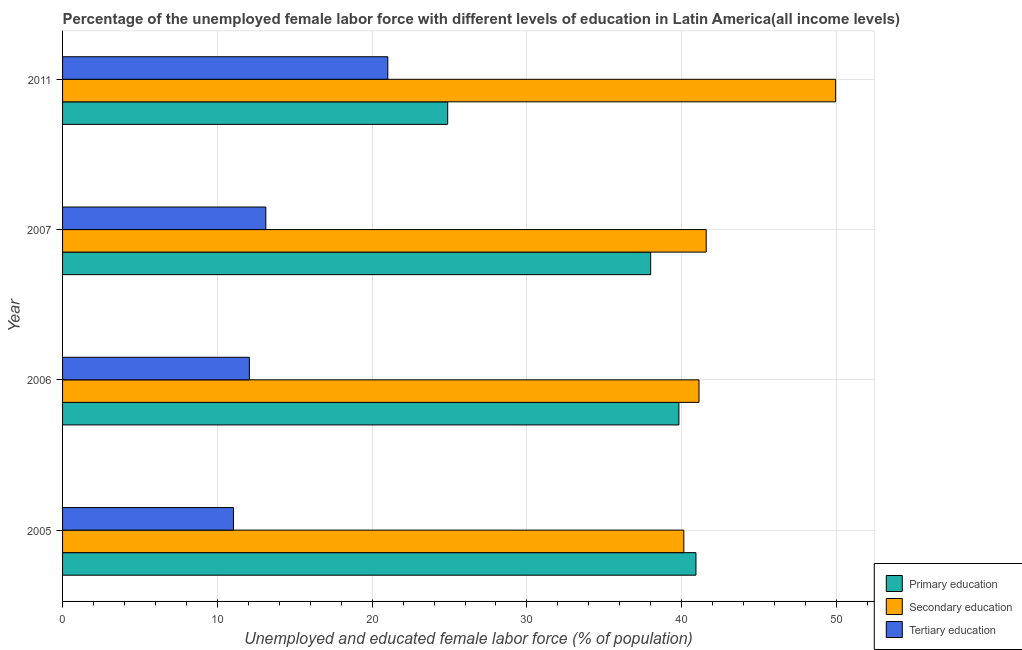How many different coloured bars are there?
Keep it short and to the point. 3. How many groups of bars are there?
Make the answer very short. 4. How many bars are there on the 2nd tick from the bottom?
Provide a short and direct response. 3. What is the label of the 2nd group of bars from the top?
Offer a terse response. 2007. In how many cases, is the number of bars for a given year not equal to the number of legend labels?
Offer a very short reply. 0. What is the percentage of female labor force who received secondary education in 2007?
Keep it short and to the point. 41.58. Across all years, what is the maximum percentage of female labor force who received tertiary education?
Give a very brief answer. 21.01. Across all years, what is the minimum percentage of female labor force who received primary education?
Your answer should be compact. 24.88. In which year was the percentage of female labor force who received tertiary education maximum?
Ensure brevity in your answer.  2011. In which year was the percentage of female labor force who received primary education minimum?
Keep it short and to the point. 2011. What is the total percentage of female labor force who received tertiary education in the graph?
Offer a terse response. 57.26. What is the difference between the percentage of female labor force who received tertiary education in 2005 and that in 2007?
Provide a succinct answer. -2.09. What is the difference between the percentage of female labor force who received tertiary education in 2007 and the percentage of female labor force who received secondary education in 2005?
Make the answer very short. -27. What is the average percentage of female labor force who received primary education per year?
Ensure brevity in your answer.  35.9. In the year 2006, what is the difference between the percentage of female labor force who received secondary education and percentage of female labor force who received tertiary education?
Keep it short and to the point. 29.05. In how many years, is the percentage of female labor force who received tertiary education greater than 46 %?
Offer a terse response. 0. What is the ratio of the percentage of female labor force who received primary education in 2007 to that in 2011?
Keep it short and to the point. 1.53. Is the percentage of female labor force who received secondary education in 2006 less than that in 2011?
Provide a short and direct response. Yes. Is the difference between the percentage of female labor force who received primary education in 2005 and 2007 greater than the difference between the percentage of female labor force who received tertiary education in 2005 and 2007?
Ensure brevity in your answer.  Yes. What is the difference between the highest and the second highest percentage of female labor force who received secondary education?
Make the answer very short. 8.36. What is the difference between the highest and the lowest percentage of female labor force who received primary education?
Ensure brevity in your answer.  16.04. What does the 3rd bar from the top in 2006 represents?
Your answer should be very brief. Primary education. What does the 1st bar from the bottom in 2005 represents?
Keep it short and to the point. Primary education. Is it the case that in every year, the sum of the percentage of female labor force who received primary education and percentage of female labor force who received secondary education is greater than the percentage of female labor force who received tertiary education?
Your answer should be very brief. Yes. How many bars are there?
Your response must be concise. 12. Are all the bars in the graph horizontal?
Make the answer very short. Yes. How many years are there in the graph?
Provide a succinct answer. 4. What is the difference between two consecutive major ticks on the X-axis?
Provide a succinct answer. 10. Are the values on the major ticks of X-axis written in scientific E-notation?
Your answer should be compact. No. Does the graph contain any zero values?
Provide a short and direct response. No. Where does the legend appear in the graph?
Offer a very short reply. Bottom right. What is the title of the graph?
Provide a succinct answer. Percentage of the unemployed female labor force with different levels of education in Latin America(all income levels). What is the label or title of the X-axis?
Give a very brief answer. Unemployed and educated female labor force (% of population). What is the Unemployed and educated female labor force (% of population) of Primary education in 2005?
Your answer should be compact. 40.92. What is the Unemployed and educated female labor force (% of population) of Secondary education in 2005?
Your response must be concise. 40.14. What is the Unemployed and educated female labor force (% of population) in Tertiary education in 2005?
Offer a terse response. 11.04. What is the Unemployed and educated female labor force (% of population) of Primary education in 2006?
Make the answer very short. 39.82. What is the Unemployed and educated female labor force (% of population) in Secondary education in 2006?
Ensure brevity in your answer.  41.12. What is the Unemployed and educated female labor force (% of population) in Tertiary education in 2006?
Provide a succinct answer. 12.07. What is the Unemployed and educated female labor force (% of population) in Primary education in 2007?
Your answer should be very brief. 38. What is the Unemployed and educated female labor force (% of population) in Secondary education in 2007?
Offer a terse response. 41.58. What is the Unemployed and educated female labor force (% of population) in Tertiary education in 2007?
Provide a short and direct response. 13.13. What is the Unemployed and educated female labor force (% of population) of Primary education in 2011?
Make the answer very short. 24.88. What is the Unemployed and educated female labor force (% of population) of Secondary education in 2011?
Your answer should be compact. 49.94. What is the Unemployed and educated female labor force (% of population) in Tertiary education in 2011?
Offer a very short reply. 21.01. Across all years, what is the maximum Unemployed and educated female labor force (% of population) of Primary education?
Your answer should be compact. 40.92. Across all years, what is the maximum Unemployed and educated female labor force (% of population) in Secondary education?
Keep it short and to the point. 49.94. Across all years, what is the maximum Unemployed and educated female labor force (% of population) in Tertiary education?
Offer a terse response. 21.01. Across all years, what is the minimum Unemployed and educated female labor force (% of population) in Primary education?
Make the answer very short. 24.88. Across all years, what is the minimum Unemployed and educated female labor force (% of population) in Secondary education?
Your response must be concise. 40.14. Across all years, what is the minimum Unemployed and educated female labor force (% of population) of Tertiary education?
Your answer should be compact. 11.04. What is the total Unemployed and educated female labor force (% of population) in Primary education in the graph?
Ensure brevity in your answer.  143.62. What is the total Unemployed and educated female labor force (% of population) in Secondary education in the graph?
Your answer should be compact. 172.78. What is the total Unemployed and educated female labor force (% of population) of Tertiary education in the graph?
Give a very brief answer. 57.26. What is the difference between the Unemployed and educated female labor force (% of population) in Primary education in 2005 and that in 2006?
Your response must be concise. 1.1. What is the difference between the Unemployed and educated female labor force (% of population) of Secondary education in 2005 and that in 2006?
Your answer should be very brief. -0.98. What is the difference between the Unemployed and educated female labor force (% of population) of Tertiary education in 2005 and that in 2006?
Provide a short and direct response. -1.03. What is the difference between the Unemployed and educated female labor force (% of population) of Primary education in 2005 and that in 2007?
Your response must be concise. 2.92. What is the difference between the Unemployed and educated female labor force (% of population) in Secondary education in 2005 and that in 2007?
Keep it short and to the point. -1.45. What is the difference between the Unemployed and educated female labor force (% of population) in Tertiary education in 2005 and that in 2007?
Keep it short and to the point. -2.09. What is the difference between the Unemployed and educated female labor force (% of population) in Primary education in 2005 and that in 2011?
Provide a short and direct response. 16.04. What is the difference between the Unemployed and educated female labor force (% of population) in Secondary education in 2005 and that in 2011?
Your response must be concise. -9.81. What is the difference between the Unemployed and educated female labor force (% of population) in Tertiary education in 2005 and that in 2011?
Provide a short and direct response. -9.97. What is the difference between the Unemployed and educated female labor force (% of population) of Primary education in 2006 and that in 2007?
Offer a very short reply. 1.82. What is the difference between the Unemployed and educated female labor force (% of population) in Secondary education in 2006 and that in 2007?
Make the answer very short. -0.47. What is the difference between the Unemployed and educated female labor force (% of population) in Tertiary education in 2006 and that in 2007?
Your answer should be compact. -1.06. What is the difference between the Unemployed and educated female labor force (% of population) of Primary education in 2006 and that in 2011?
Offer a very short reply. 14.94. What is the difference between the Unemployed and educated female labor force (% of population) of Secondary education in 2006 and that in 2011?
Your answer should be compact. -8.83. What is the difference between the Unemployed and educated female labor force (% of population) in Tertiary education in 2006 and that in 2011?
Offer a terse response. -8.94. What is the difference between the Unemployed and educated female labor force (% of population) of Primary education in 2007 and that in 2011?
Your response must be concise. 13.12. What is the difference between the Unemployed and educated female labor force (% of population) of Secondary education in 2007 and that in 2011?
Keep it short and to the point. -8.36. What is the difference between the Unemployed and educated female labor force (% of population) in Tertiary education in 2007 and that in 2011?
Your answer should be very brief. -7.88. What is the difference between the Unemployed and educated female labor force (% of population) in Primary education in 2005 and the Unemployed and educated female labor force (% of population) in Secondary education in 2006?
Provide a short and direct response. -0.2. What is the difference between the Unemployed and educated female labor force (% of population) in Primary education in 2005 and the Unemployed and educated female labor force (% of population) in Tertiary education in 2006?
Make the answer very short. 28.85. What is the difference between the Unemployed and educated female labor force (% of population) of Secondary education in 2005 and the Unemployed and educated female labor force (% of population) of Tertiary education in 2006?
Ensure brevity in your answer.  28.07. What is the difference between the Unemployed and educated female labor force (% of population) of Primary education in 2005 and the Unemployed and educated female labor force (% of population) of Secondary education in 2007?
Your response must be concise. -0.66. What is the difference between the Unemployed and educated female labor force (% of population) of Primary education in 2005 and the Unemployed and educated female labor force (% of population) of Tertiary education in 2007?
Keep it short and to the point. 27.79. What is the difference between the Unemployed and educated female labor force (% of population) of Secondary education in 2005 and the Unemployed and educated female labor force (% of population) of Tertiary education in 2007?
Your answer should be very brief. 27. What is the difference between the Unemployed and educated female labor force (% of population) of Primary education in 2005 and the Unemployed and educated female labor force (% of population) of Secondary education in 2011?
Provide a succinct answer. -9.02. What is the difference between the Unemployed and educated female labor force (% of population) in Primary education in 2005 and the Unemployed and educated female labor force (% of population) in Tertiary education in 2011?
Your response must be concise. 19.91. What is the difference between the Unemployed and educated female labor force (% of population) of Secondary education in 2005 and the Unemployed and educated female labor force (% of population) of Tertiary education in 2011?
Provide a succinct answer. 19.12. What is the difference between the Unemployed and educated female labor force (% of population) in Primary education in 2006 and the Unemployed and educated female labor force (% of population) in Secondary education in 2007?
Offer a terse response. -1.76. What is the difference between the Unemployed and educated female labor force (% of population) in Primary education in 2006 and the Unemployed and educated female labor force (% of population) in Tertiary education in 2007?
Ensure brevity in your answer.  26.69. What is the difference between the Unemployed and educated female labor force (% of population) in Secondary education in 2006 and the Unemployed and educated female labor force (% of population) in Tertiary education in 2007?
Offer a very short reply. 27.99. What is the difference between the Unemployed and educated female labor force (% of population) in Primary education in 2006 and the Unemployed and educated female labor force (% of population) in Secondary education in 2011?
Provide a succinct answer. -10.13. What is the difference between the Unemployed and educated female labor force (% of population) in Primary education in 2006 and the Unemployed and educated female labor force (% of population) in Tertiary education in 2011?
Offer a terse response. 18.81. What is the difference between the Unemployed and educated female labor force (% of population) of Secondary education in 2006 and the Unemployed and educated female labor force (% of population) of Tertiary education in 2011?
Your answer should be compact. 20.1. What is the difference between the Unemployed and educated female labor force (% of population) in Primary education in 2007 and the Unemployed and educated female labor force (% of population) in Secondary education in 2011?
Ensure brevity in your answer.  -11.95. What is the difference between the Unemployed and educated female labor force (% of population) of Primary education in 2007 and the Unemployed and educated female labor force (% of population) of Tertiary education in 2011?
Your response must be concise. 16.98. What is the difference between the Unemployed and educated female labor force (% of population) of Secondary education in 2007 and the Unemployed and educated female labor force (% of population) of Tertiary education in 2011?
Your response must be concise. 20.57. What is the average Unemployed and educated female labor force (% of population) in Primary education per year?
Your answer should be compact. 35.9. What is the average Unemployed and educated female labor force (% of population) in Secondary education per year?
Keep it short and to the point. 43.19. What is the average Unemployed and educated female labor force (% of population) in Tertiary education per year?
Offer a terse response. 14.31. In the year 2005, what is the difference between the Unemployed and educated female labor force (% of population) of Primary education and Unemployed and educated female labor force (% of population) of Secondary education?
Your response must be concise. 0.78. In the year 2005, what is the difference between the Unemployed and educated female labor force (% of population) in Primary education and Unemployed and educated female labor force (% of population) in Tertiary education?
Your response must be concise. 29.88. In the year 2005, what is the difference between the Unemployed and educated female labor force (% of population) of Secondary education and Unemployed and educated female labor force (% of population) of Tertiary education?
Offer a terse response. 29.1. In the year 2006, what is the difference between the Unemployed and educated female labor force (% of population) of Primary education and Unemployed and educated female labor force (% of population) of Secondary education?
Provide a succinct answer. -1.3. In the year 2006, what is the difference between the Unemployed and educated female labor force (% of population) of Primary education and Unemployed and educated female labor force (% of population) of Tertiary education?
Offer a very short reply. 27.75. In the year 2006, what is the difference between the Unemployed and educated female labor force (% of population) in Secondary education and Unemployed and educated female labor force (% of population) in Tertiary education?
Your answer should be very brief. 29.05. In the year 2007, what is the difference between the Unemployed and educated female labor force (% of population) in Primary education and Unemployed and educated female labor force (% of population) in Secondary education?
Make the answer very short. -3.59. In the year 2007, what is the difference between the Unemployed and educated female labor force (% of population) of Primary education and Unemployed and educated female labor force (% of population) of Tertiary education?
Your response must be concise. 24.86. In the year 2007, what is the difference between the Unemployed and educated female labor force (% of population) of Secondary education and Unemployed and educated female labor force (% of population) of Tertiary education?
Offer a terse response. 28.45. In the year 2011, what is the difference between the Unemployed and educated female labor force (% of population) of Primary education and Unemployed and educated female labor force (% of population) of Secondary education?
Your answer should be very brief. -25.06. In the year 2011, what is the difference between the Unemployed and educated female labor force (% of population) of Primary education and Unemployed and educated female labor force (% of population) of Tertiary education?
Make the answer very short. 3.87. In the year 2011, what is the difference between the Unemployed and educated female labor force (% of population) in Secondary education and Unemployed and educated female labor force (% of population) in Tertiary education?
Provide a short and direct response. 28.93. What is the ratio of the Unemployed and educated female labor force (% of population) of Primary education in 2005 to that in 2006?
Provide a succinct answer. 1.03. What is the ratio of the Unemployed and educated female labor force (% of population) of Secondary education in 2005 to that in 2006?
Provide a short and direct response. 0.98. What is the ratio of the Unemployed and educated female labor force (% of population) of Tertiary education in 2005 to that in 2006?
Offer a terse response. 0.91. What is the ratio of the Unemployed and educated female labor force (% of population) in Primary education in 2005 to that in 2007?
Give a very brief answer. 1.08. What is the ratio of the Unemployed and educated female labor force (% of population) of Secondary education in 2005 to that in 2007?
Your answer should be very brief. 0.97. What is the ratio of the Unemployed and educated female labor force (% of population) in Tertiary education in 2005 to that in 2007?
Give a very brief answer. 0.84. What is the ratio of the Unemployed and educated female labor force (% of population) in Primary education in 2005 to that in 2011?
Your response must be concise. 1.64. What is the ratio of the Unemployed and educated female labor force (% of population) of Secondary education in 2005 to that in 2011?
Make the answer very short. 0.8. What is the ratio of the Unemployed and educated female labor force (% of population) in Tertiary education in 2005 to that in 2011?
Offer a very short reply. 0.53. What is the ratio of the Unemployed and educated female labor force (% of population) in Primary education in 2006 to that in 2007?
Keep it short and to the point. 1.05. What is the ratio of the Unemployed and educated female labor force (% of population) of Tertiary education in 2006 to that in 2007?
Your answer should be compact. 0.92. What is the ratio of the Unemployed and educated female labor force (% of population) of Primary education in 2006 to that in 2011?
Make the answer very short. 1.6. What is the ratio of the Unemployed and educated female labor force (% of population) in Secondary education in 2006 to that in 2011?
Your answer should be compact. 0.82. What is the ratio of the Unemployed and educated female labor force (% of population) of Tertiary education in 2006 to that in 2011?
Your answer should be compact. 0.57. What is the ratio of the Unemployed and educated female labor force (% of population) in Primary education in 2007 to that in 2011?
Your answer should be compact. 1.53. What is the ratio of the Unemployed and educated female labor force (% of population) in Secondary education in 2007 to that in 2011?
Provide a short and direct response. 0.83. What is the ratio of the Unemployed and educated female labor force (% of population) of Tertiary education in 2007 to that in 2011?
Provide a short and direct response. 0.62. What is the difference between the highest and the second highest Unemployed and educated female labor force (% of population) in Primary education?
Ensure brevity in your answer.  1.1. What is the difference between the highest and the second highest Unemployed and educated female labor force (% of population) of Secondary education?
Ensure brevity in your answer.  8.36. What is the difference between the highest and the second highest Unemployed and educated female labor force (% of population) in Tertiary education?
Make the answer very short. 7.88. What is the difference between the highest and the lowest Unemployed and educated female labor force (% of population) in Primary education?
Provide a short and direct response. 16.04. What is the difference between the highest and the lowest Unemployed and educated female labor force (% of population) of Secondary education?
Offer a very short reply. 9.81. What is the difference between the highest and the lowest Unemployed and educated female labor force (% of population) of Tertiary education?
Make the answer very short. 9.97. 